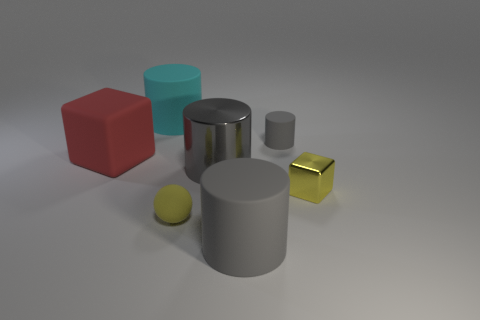How many gray cylinders must be subtracted to get 1 gray cylinders? 2 Subtract all cyan cylinders. How many cylinders are left? 3 Subtract 1 spheres. How many spheres are left? 0 Subtract all cyan cylinders. How many cylinders are left? 3 Add 3 big gray cylinders. How many objects exist? 10 Subtract all blue balls. How many gray cylinders are left? 3 Subtract 0 purple blocks. How many objects are left? 7 Subtract all balls. How many objects are left? 6 Subtract all blue blocks. Subtract all green balls. How many blocks are left? 2 Subtract all big red objects. Subtract all blue shiny cylinders. How many objects are left? 6 